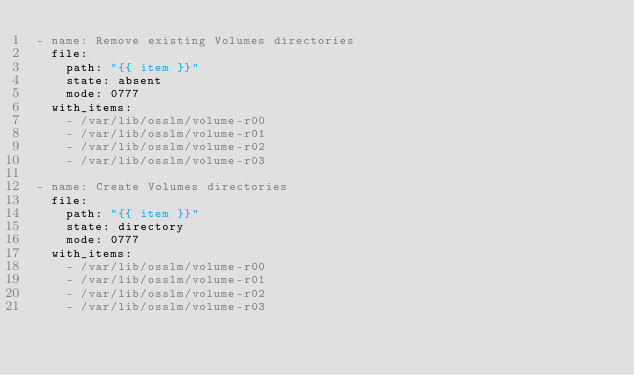Convert code to text. <code><loc_0><loc_0><loc_500><loc_500><_YAML_>- name: Remove existing Volumes directories
  file:
    path: "{{ item }}"
    state: absent
    mode: 0777
  with_items:
    - /var/lib/osslm/volume-r00
    - /var/lib/osslm/volume-r01
    - /var/lib/osslm/volume-r02
    - /var/lib/osslm/volume-r03

- name: Create Volumes directories
  file:
    path: "{{ item }}"
    state: directory
    mode: 0777
  with_items:
    - /var/lib/osslm/volume-r00
    - /var/lib/osslm/volume-r01
    - /var/lib/osslm/volume-r02
    - /var/lib/osslm/volume-r03</code> 